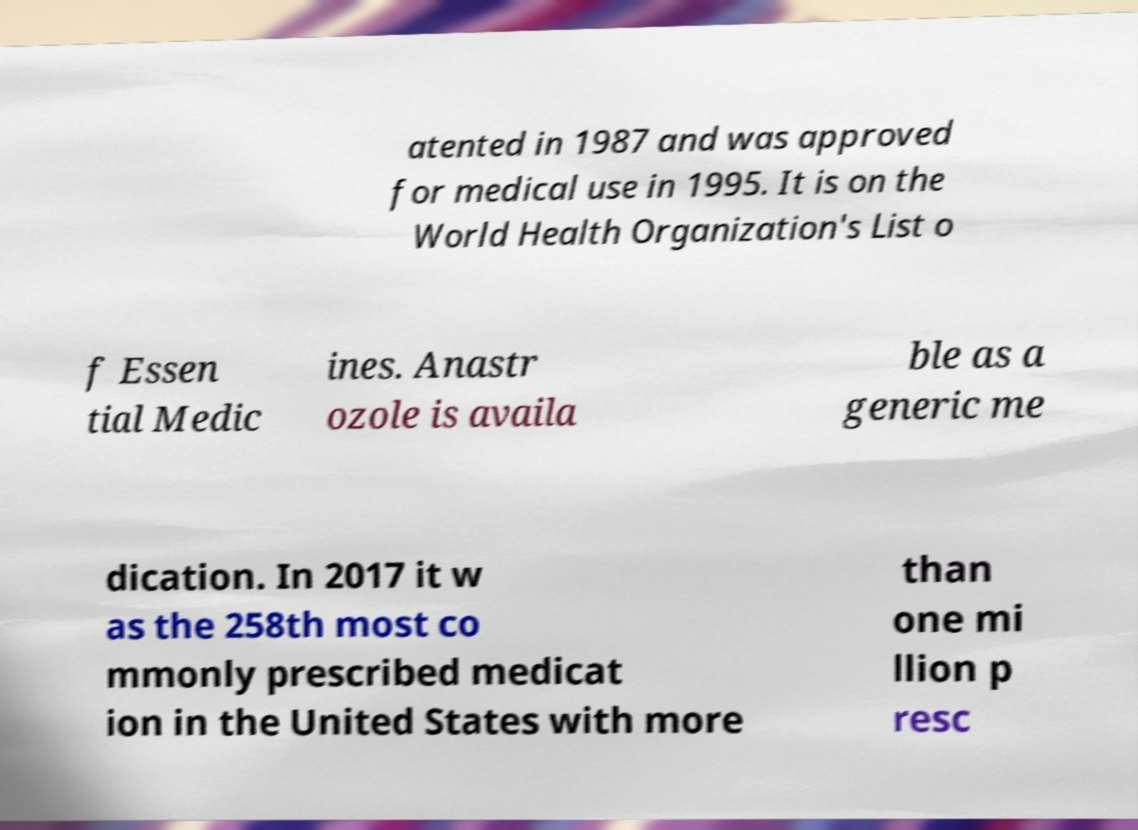For documentation purposes, I need the text within this image transcribed. Could you provide that? atented in 1987 and was approved for medical use in 1995. It is on the World Health Organization's List o f Essen tial Medic ines. Anastr ozole is availa ble as a generic me dication. In 2017 it w as the 258th most co mmonly prescribed medicat ion in the United States with more than one mi llion p resc 